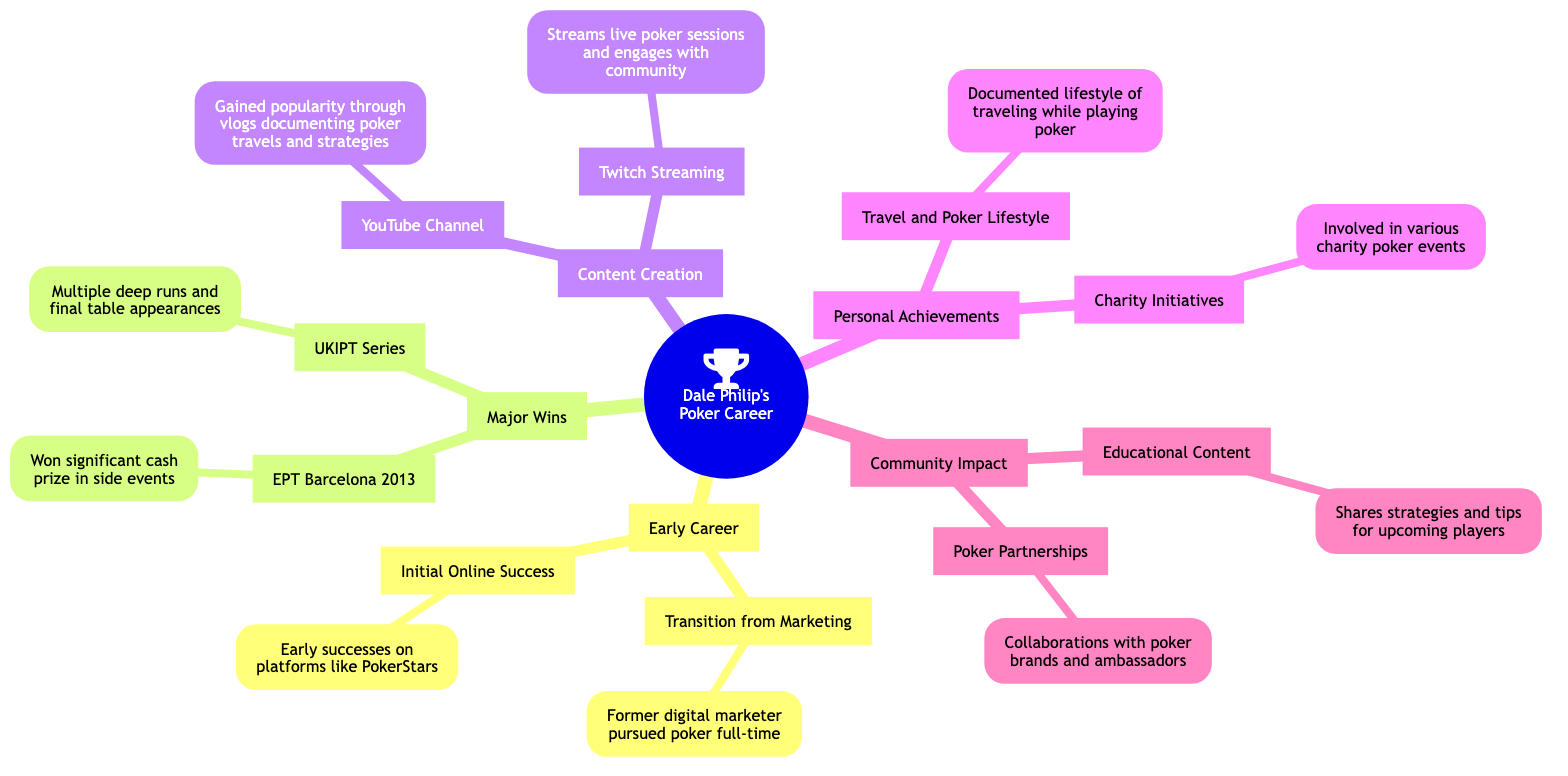What's the primary focus of Dale Philip's career? The main topic of the diagram clearly states that the focus is on key highlights from Dale Philip's poker career.
Answer: Key Highlights from Dale Philip's Poker Career How many major wins are listed? The diagram contains one main node titled "Major Wins" which includes two subnodes: "EPT Barcelona 2013" and "UKIPT Series", indicating there are a total of 2 major wins.
Answer: 2 What year did Dale Philip achieve success at EPT Barcelona? The subnode "EPT Barcelona 2013" under the "Major Wins" node indicates the year of this achievement.
Answer: 2013 What type of content does Dale Philip produce? The node titled "Content Creation" has two subnodes: "YouTube Channel" and "Twitch Streaming," which clarifies the types of content produced.
Answer: YouTube Channel and Twitch Streaming How does Dale Philip engage with the poker community? The subnode "Twitch Streaming" under "Content Creation" specifies that he streams live sessions and engages with the community, revealing his way of interaction.
Answer: Streams live poker sessions What are Dale's achievements in terms of lifestyle? The subnode "Travel and Poker Lifestyle" under "Personal Achievements" documents his lifestyle while playing poker, highlighting that traveling is a significant aspect of his life.
Answer: Traveling the world while playing poker What educational activities does Dale Philip participate in? The subnode "Educational Content" under "Community Impact" shows that he shares strategies and tips, indicating his involvement in educational activities.
Answer: Shares strategies and tips Which section of the diagram addresses charity initiatives? The "Personal Achievements" node includes a subnode specifically titled "Charity Initiatives," indicating this is where charity-related information is located.
Answer: Personal Achievements What is a notable aspect of Dale Philip's personal achievements? The subnode "Travel and Poker Lifestyle" suggests a notable aspect is the combination of personal travel with professional poker playing.
Answer: Traveling while playing poker 